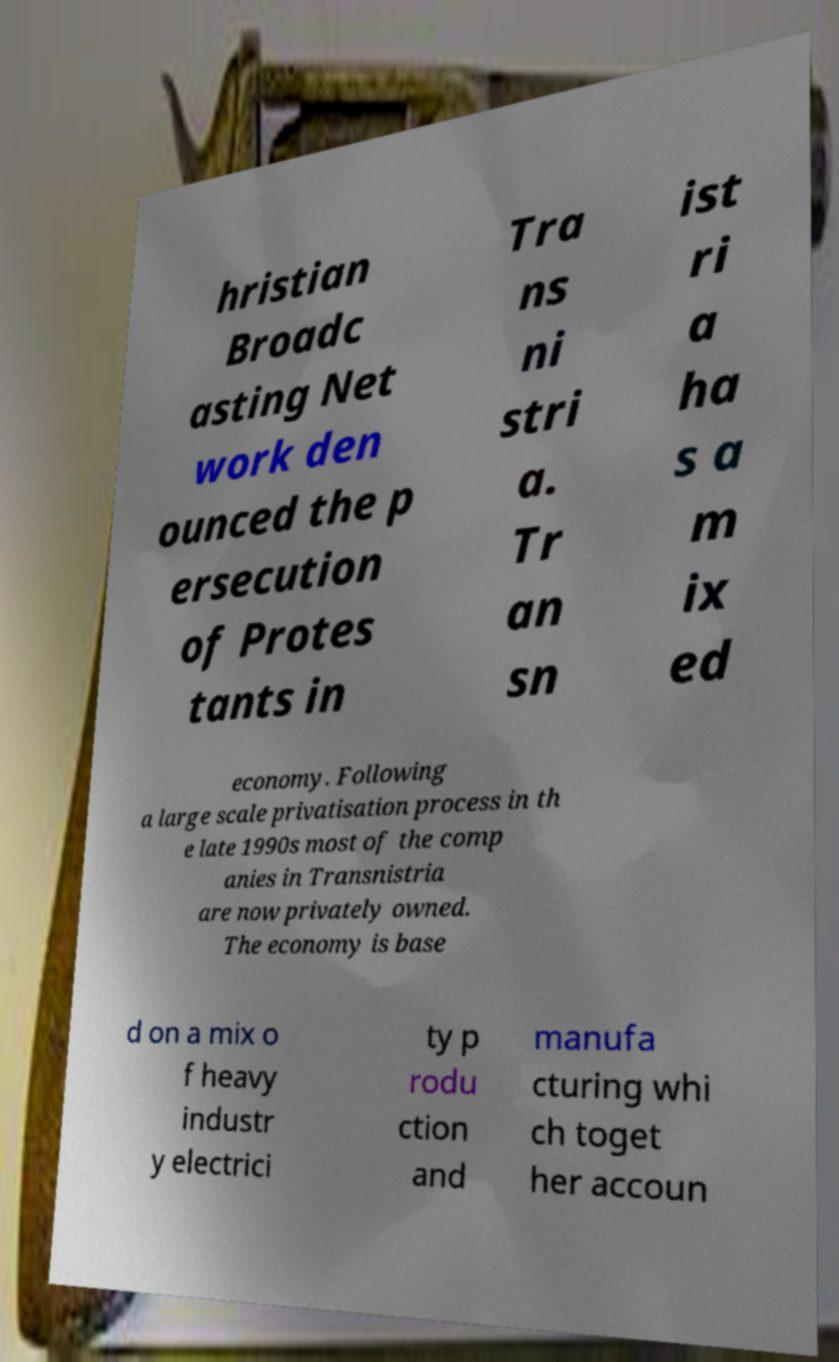There's text embedded in this image that I need extracted. Can you transcribe it verbatim? hristian Broadc asting Net work den ounced the p ersecution of Protes tants in Tra ns ni stri a. Tr an sn ist ri a ha s a m ix ed economy. Following a large scale privatisation process in th e late 1990s most of the comp anies in Transnistria are now privately owned. The economy is base d on a mix o f heavy industr y electrici ty p rodu ction and manufa cturing whi ch toget her accoun 